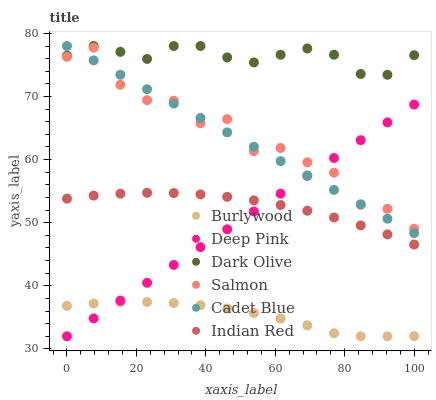Does Burlywood have the minimum area under the curve?
Answer yes or no. Yes. Does Dark Olive have the maximum area under the curve?
Answer yes or no. Yes. Does Dark Olive have the minimum area under the curve?
Answer yes or no. No. Does Burlywood have the maximum area under the curve?
Answer yes or no. No. Is Deep Pink the smoothest?
Answer yes or no. Yes. Is Salmon the roughest?
Answer yes or no. Yes. Is Burlywood the smoothest?
Answer yes or no. No. Is Burlywood the roughest?
Answer yes or no. No. Does Deep Pink have the lowest value?
Answer yes or no. Yes. Does Dark Olive have the lowest value?
Answer yes or no. No. Does Cadet Blue have the highest value?
Answer yes or no. Yes. Does Burlywood have the highest value?
Answer yes or no. No. Is Indian Red less than Dark Olive?
Answer yes or no. Yes. Is Dark Olive greater than Salmon?
Answer yes or no. Yes. Does Salmon intersect Cadet Blue?
Answer yes or no. Yes. Is Salmon less than Cadet Blue?
Answer yes or no. No. Is Salmon greater than Cadet Blue?
Answer yes or no. No. Does Indian Red intersect Dark Olive?
Answer yes or no. No. 